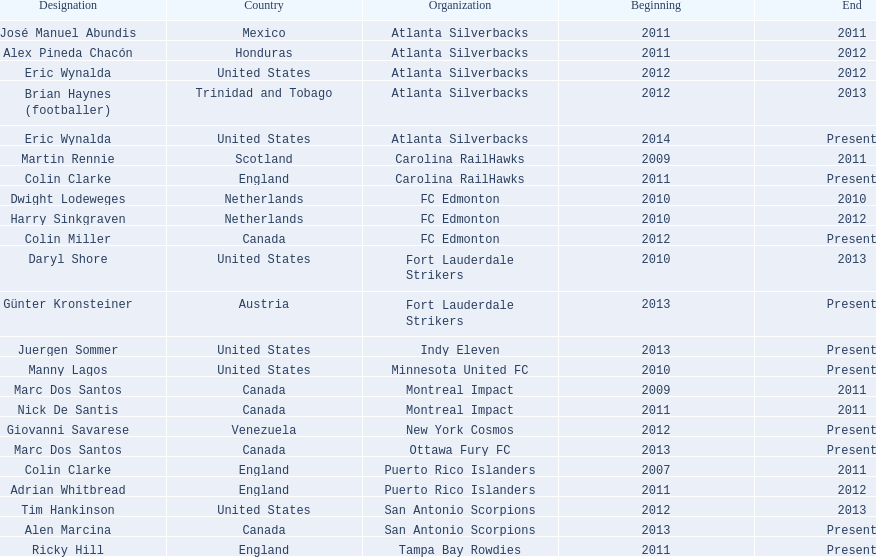What were all the coaches who were coaching in 2010? Martin Rennie, Dwight Lodeweges, Harry Sinkgraven, Daryl Shore, Manny Lagos, Marc Dos Santos, Colin Clarke. Which of the 2010 coaches were not born in north america? Martin Rennie, Dwight Lodeweges, Harry Sinkgraven, Colin Clarke. Which coaches that were coaching in 2010 and were not from north america did not coach for fc edmonton? Martin Rennie, Colin Clarke. What coach did not coach for fc edmonton in 2010 and was not north american nationality had the shortened career as a coach? Martin Rennie. 